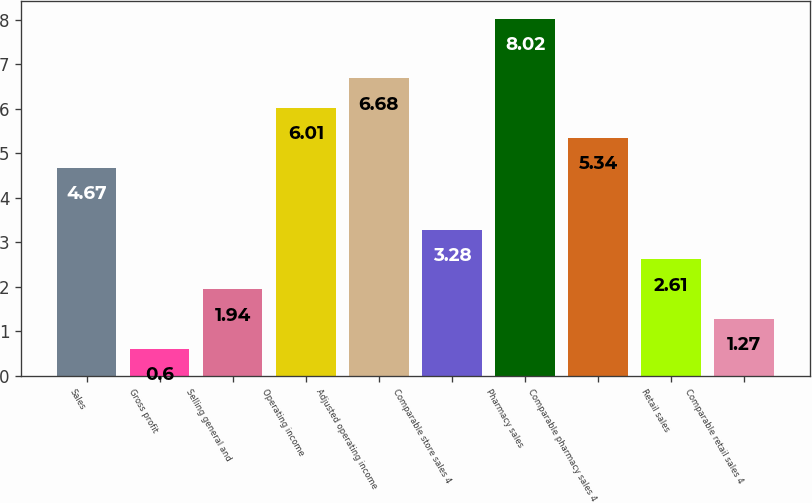Convert chart. <chart><loc_0><loc_0><loc_500><loc_500><bar_chart><fcel>Sales<fcel>Gross profit<fcel>Selling general and<fcel>Operating income<fcel>Adjusted operating income<fcel>Comparable store sales 4<fcel>Pharmacy sales<fcel>Comparable pharmacy sales 4<fcel>Retail sales<fcel>Comparable retail sales 4<nl><fcel>4.67<fcel>0.6<fcel>1.94<fcel>6.01<fcel>6.68<fcel>3.28<fcel>8.02<fcel>5.34<fcel>2.61<fcel>1.27<nl></chart> 